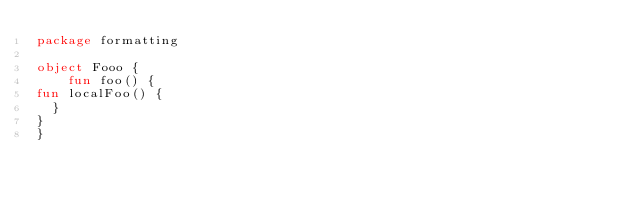Convert code to text. <code><loc_0><loc_0><loc_500><loc_500><_Kotlin_>package formatting

object Fooo {
    fun foo() {
fun localFoo() {
  }
}
}</code> 